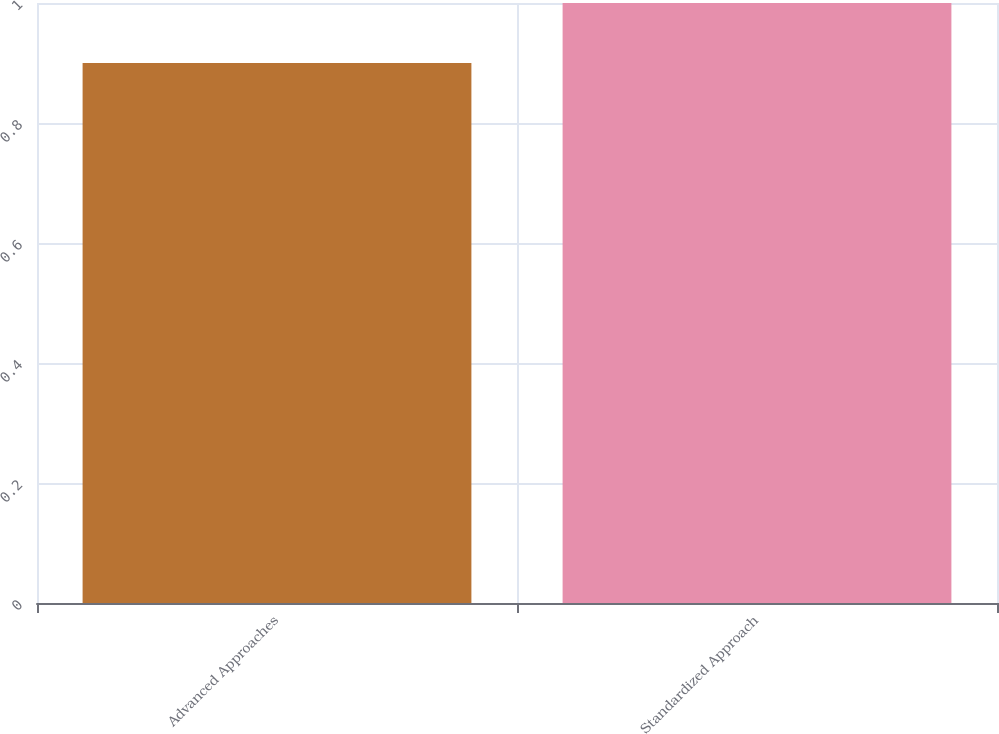<chart> <loc_0><loc_0><loc_500><loc_500><bar_chart><fcel>Advanced Approaches<fcel>Standardized Approach<nl><fcel>0.9<fcel>1<nl></chart> 